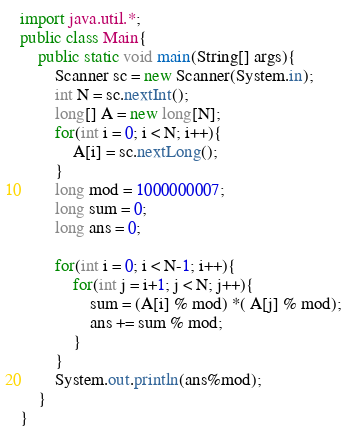<code> <loc_0><loc_0><loc_500><loc_500><_Java_>import java.util.*;
public class Main{
	public static void main(String[] args){
		Scanner sc = new Scanner(System.in);
		int N = sc.nextInt();
		long[] A = new long[N];
		for(int i = 0; i < N; i++){
			A[i] = sc.nextLong();
		}
		long mod = 1000000007;
		long sum = 0;
		long ans = 0;
		
		for(int i = 0; i < N-1; i++){
			for(int j = i+1; j < N; j++){
				sum = (A[i] % mod) *( A[j] % mod);
 				ans += sum % mod;
			}
		}
		System.out.println(ans%mod);
	}
}</code> 